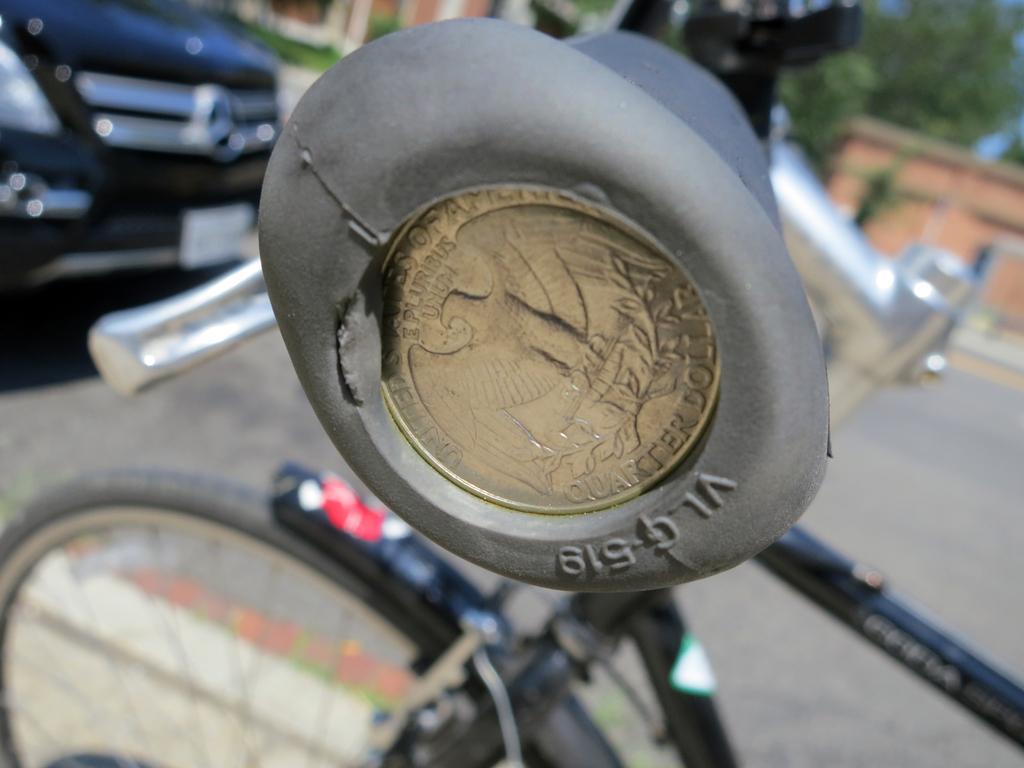Could you give a brief overview of what you see in this image? In this image we can see the handle of a bicycle. The background of the image is blurred, where we can see the bicycle, a car and trees in the background. 